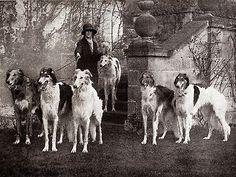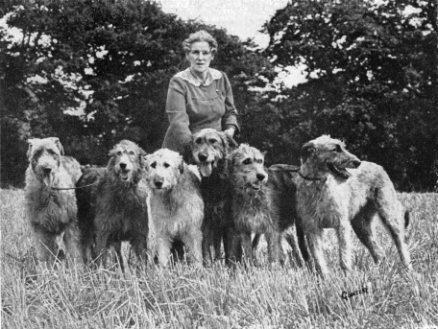The first image is the image on the left, the second image is the image on the right. Given the left and right images, does the statement "A vintage image shows a woman in a non-floor-length skirt, jacket and hat standing outdoors next to one afghan hound." hold true? Answer yes or no. No. The first image is the image on the left, the second image is the image on the right. Analyze the images presented: Is the assertion "A woman is standing with a single dog in the image on the right." valid? Answer yes or no. No. 